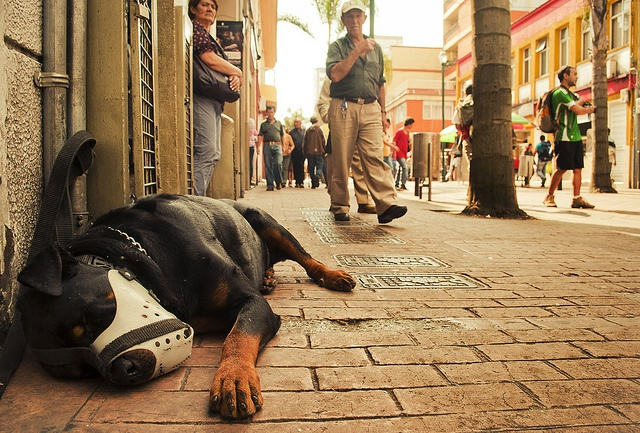Describe the objects in this image and their specific colors. I can see dog in tan, black, and maroon tones, people in tan, gray, and maroon tones, people in tan, black, gray, and maroon tones, people in tan, black, maroon, brown, and darkgreen tones, and people in tan, black, gray, and maroon tones in this image. 